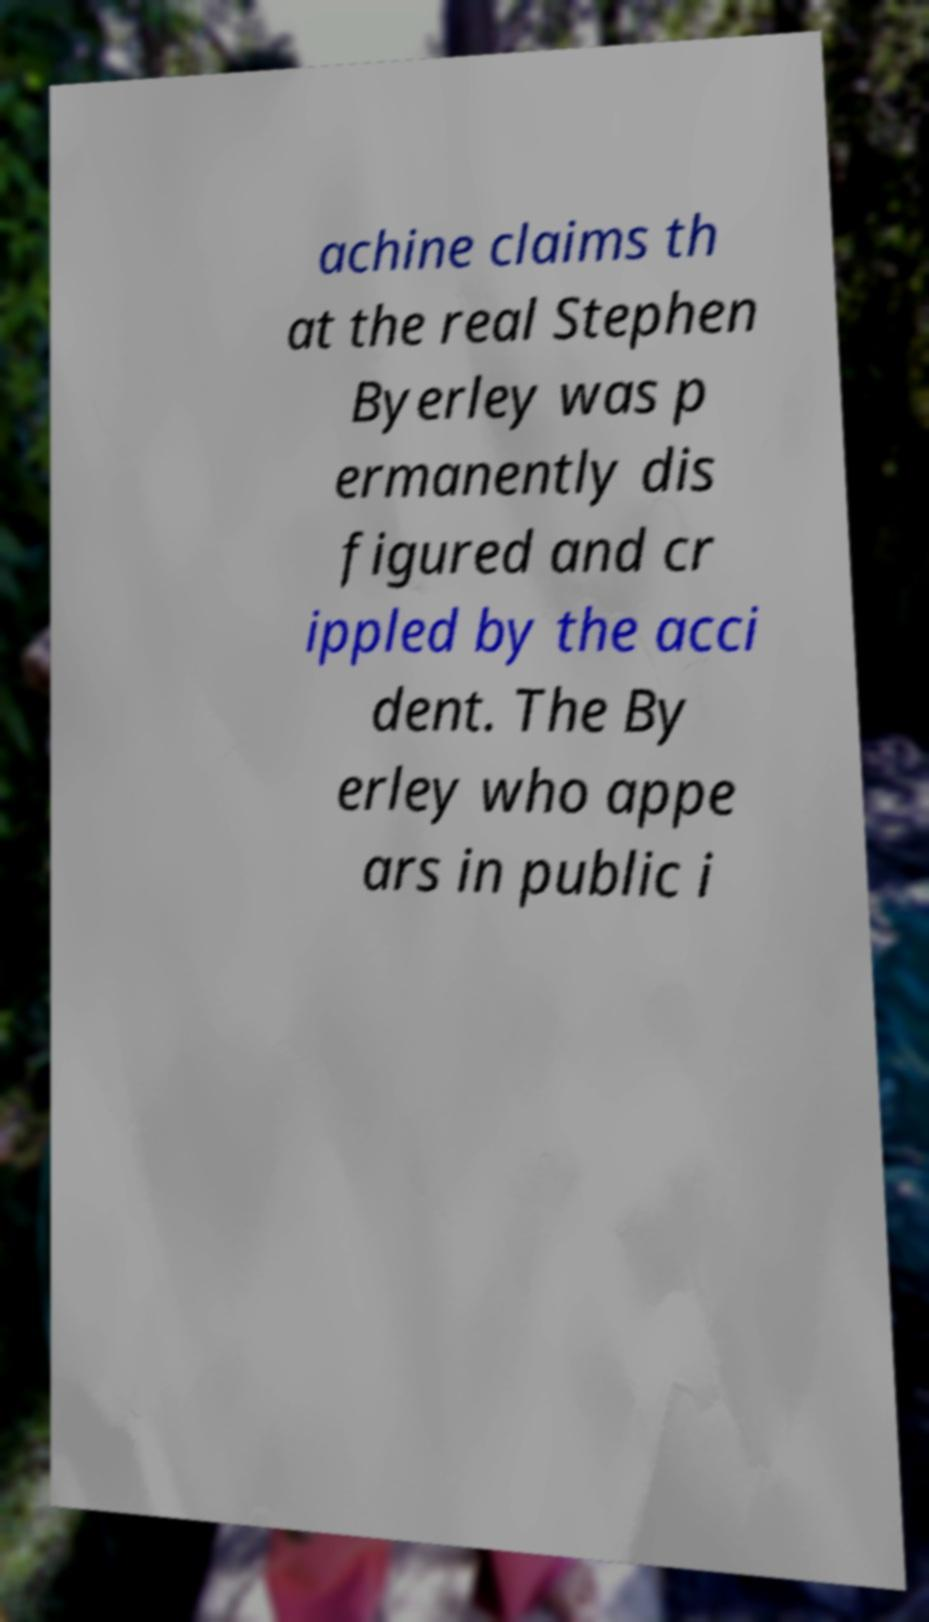Could you extract and type out the text from this image? achine claims th at the real Stephen Byerley was p ermanently dis figured and cr ippled by the acci dent. The By erley who appe ars in public i 